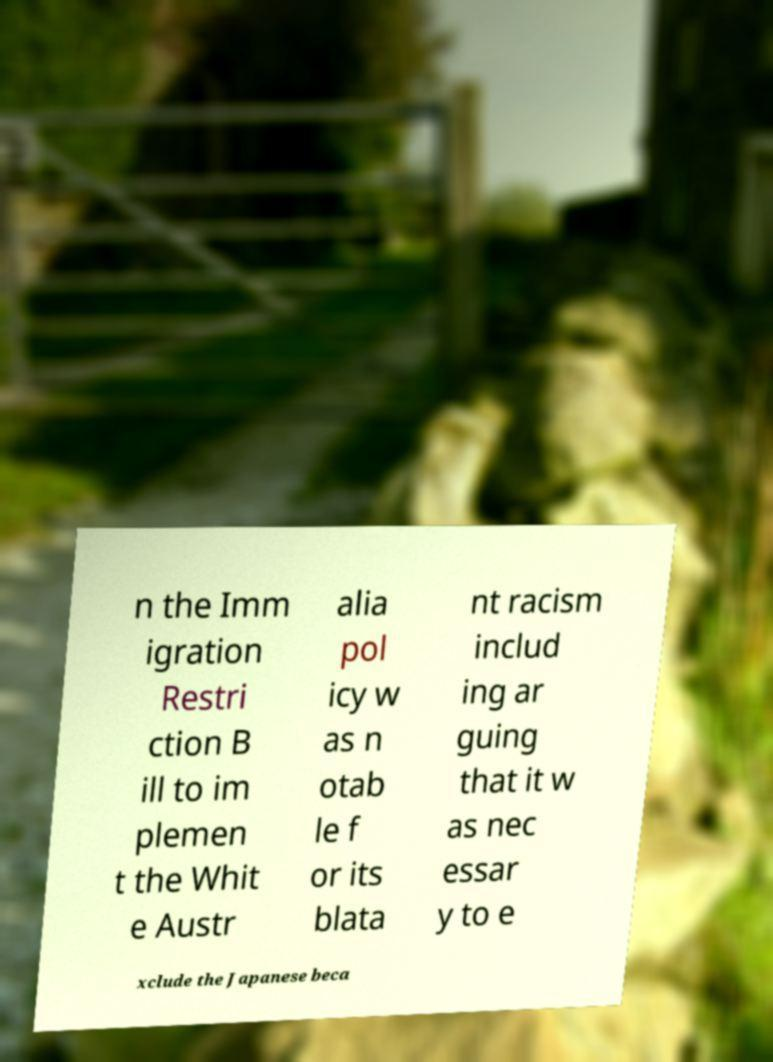Could you assist in decoding the text presented in this image and type it out clearly? n the Imm igration Restri ction B ill to im plemen t the Whit e Austr alia pol icy w as n otab le f or its blata nt racism includ ing ar guing that it w as nec essar y to e xclude the Japanese beca 